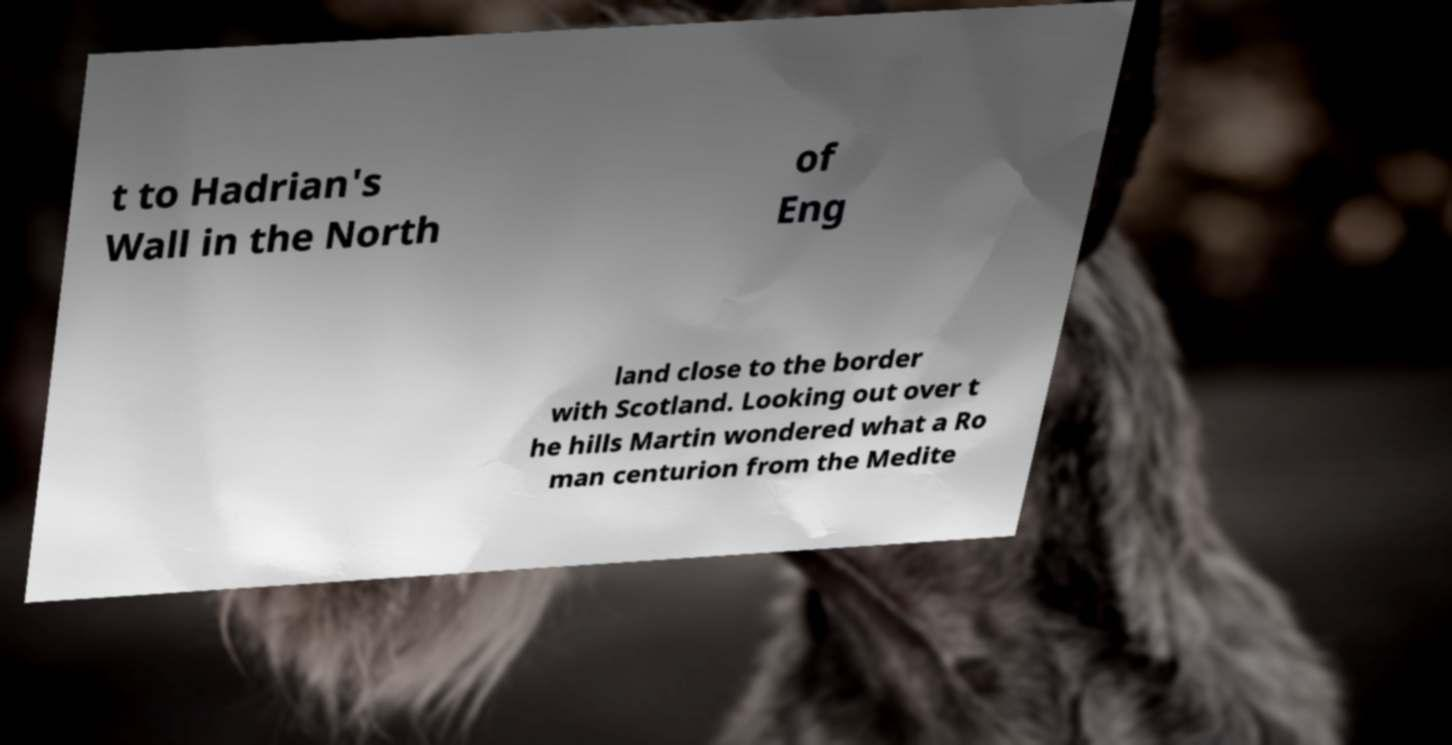I need the written content from this picture converted into text. Can you do that? t to Hadrian's Wall in the North of Eng land close to the border with Scotland. Looking out over t he hills Martin wondered what a Ro man centurion from the Medite 